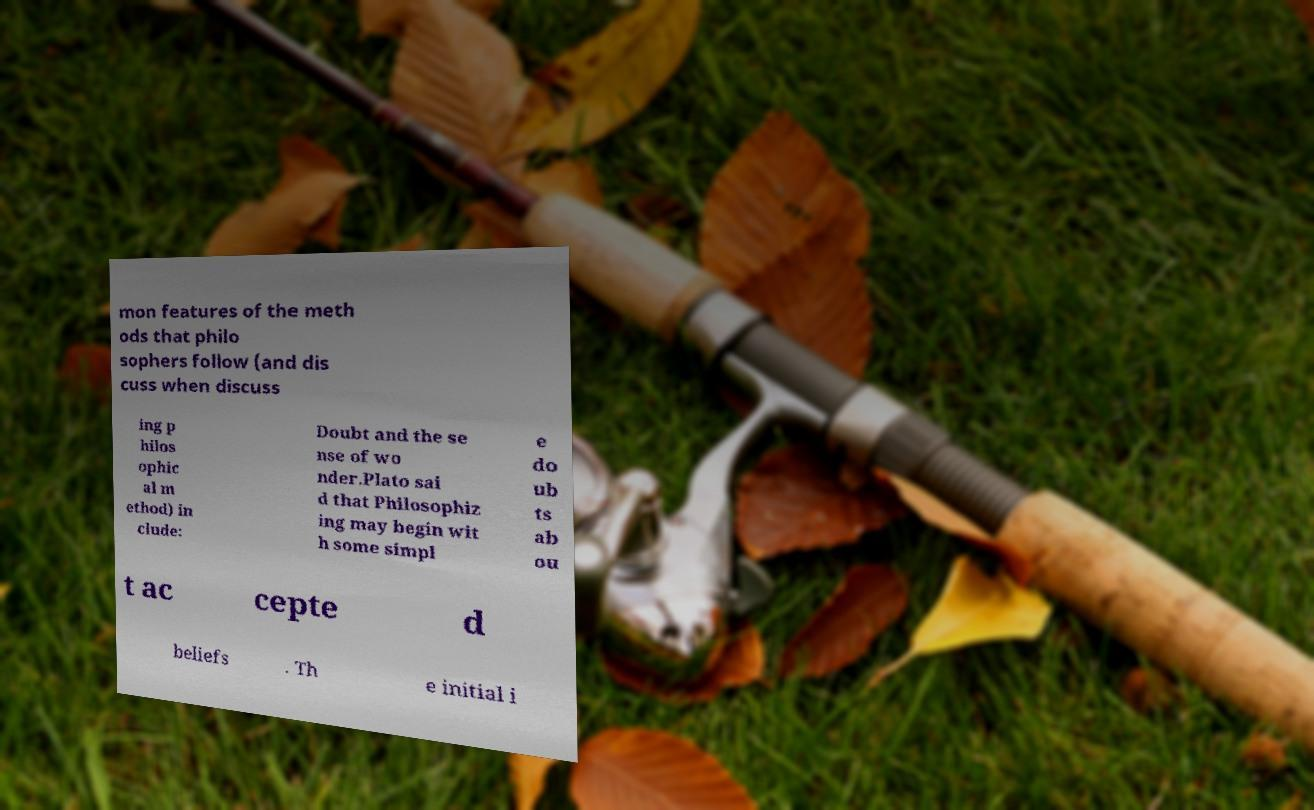What messages or text are displayed in this image? I need them in a readable, typed format. mon features of the meth ods that philo sophers follow (and dis cuss when discuss ing p hilos ophic al m ethod) in clude: Doubt and the se nse of wo nder.Plato sai d that Philosophiz ing may begin wit h some simpl e do ub ts ab ou t ac cepte d beliefs . Th e initial i 